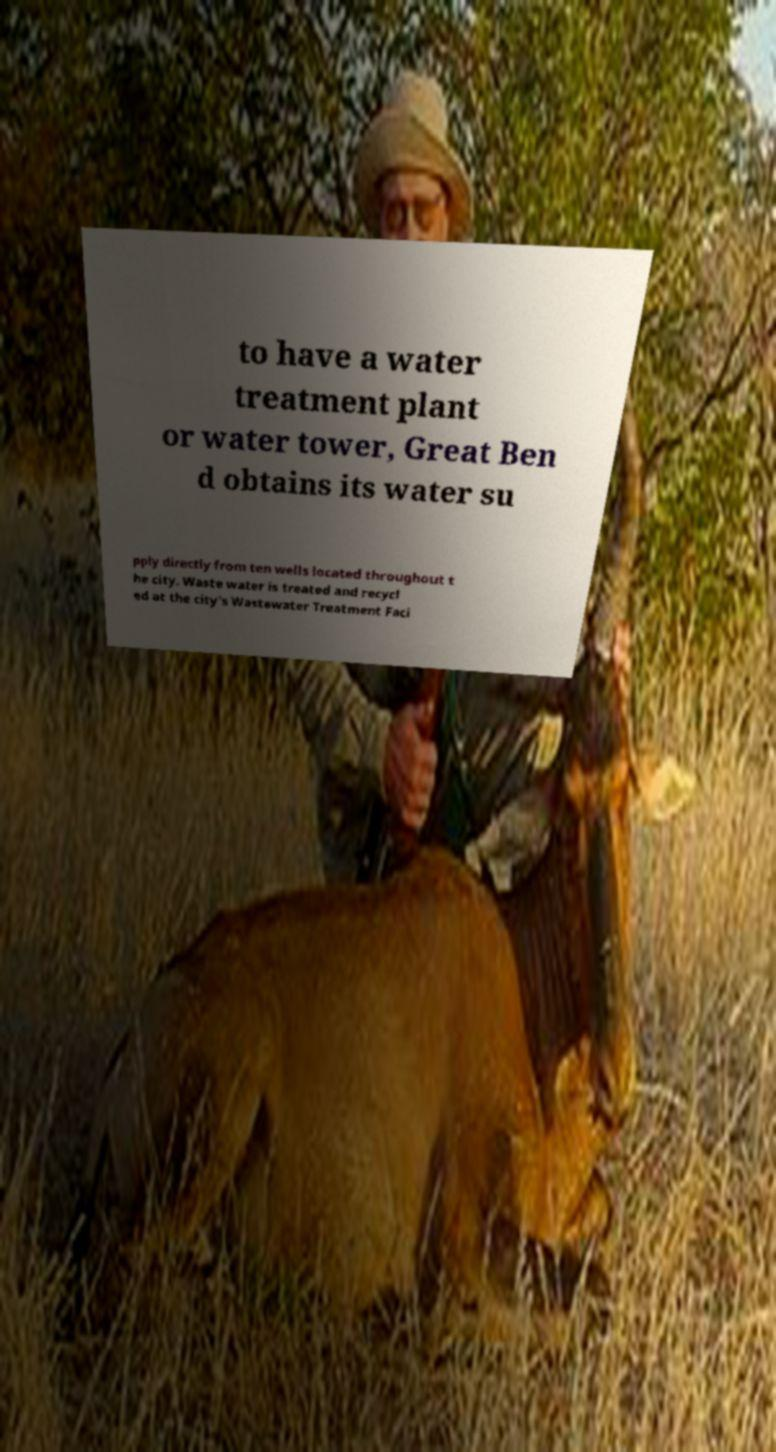Could you assist in decoding the text presented in this image and type it out clearly? to have a water treatment plant or water tower, Great Ben d obtains its water su pply directly from ten wells located throughout t he city. Waste water is treated and recycl ed at the city's Wastewater Treatment Faci 